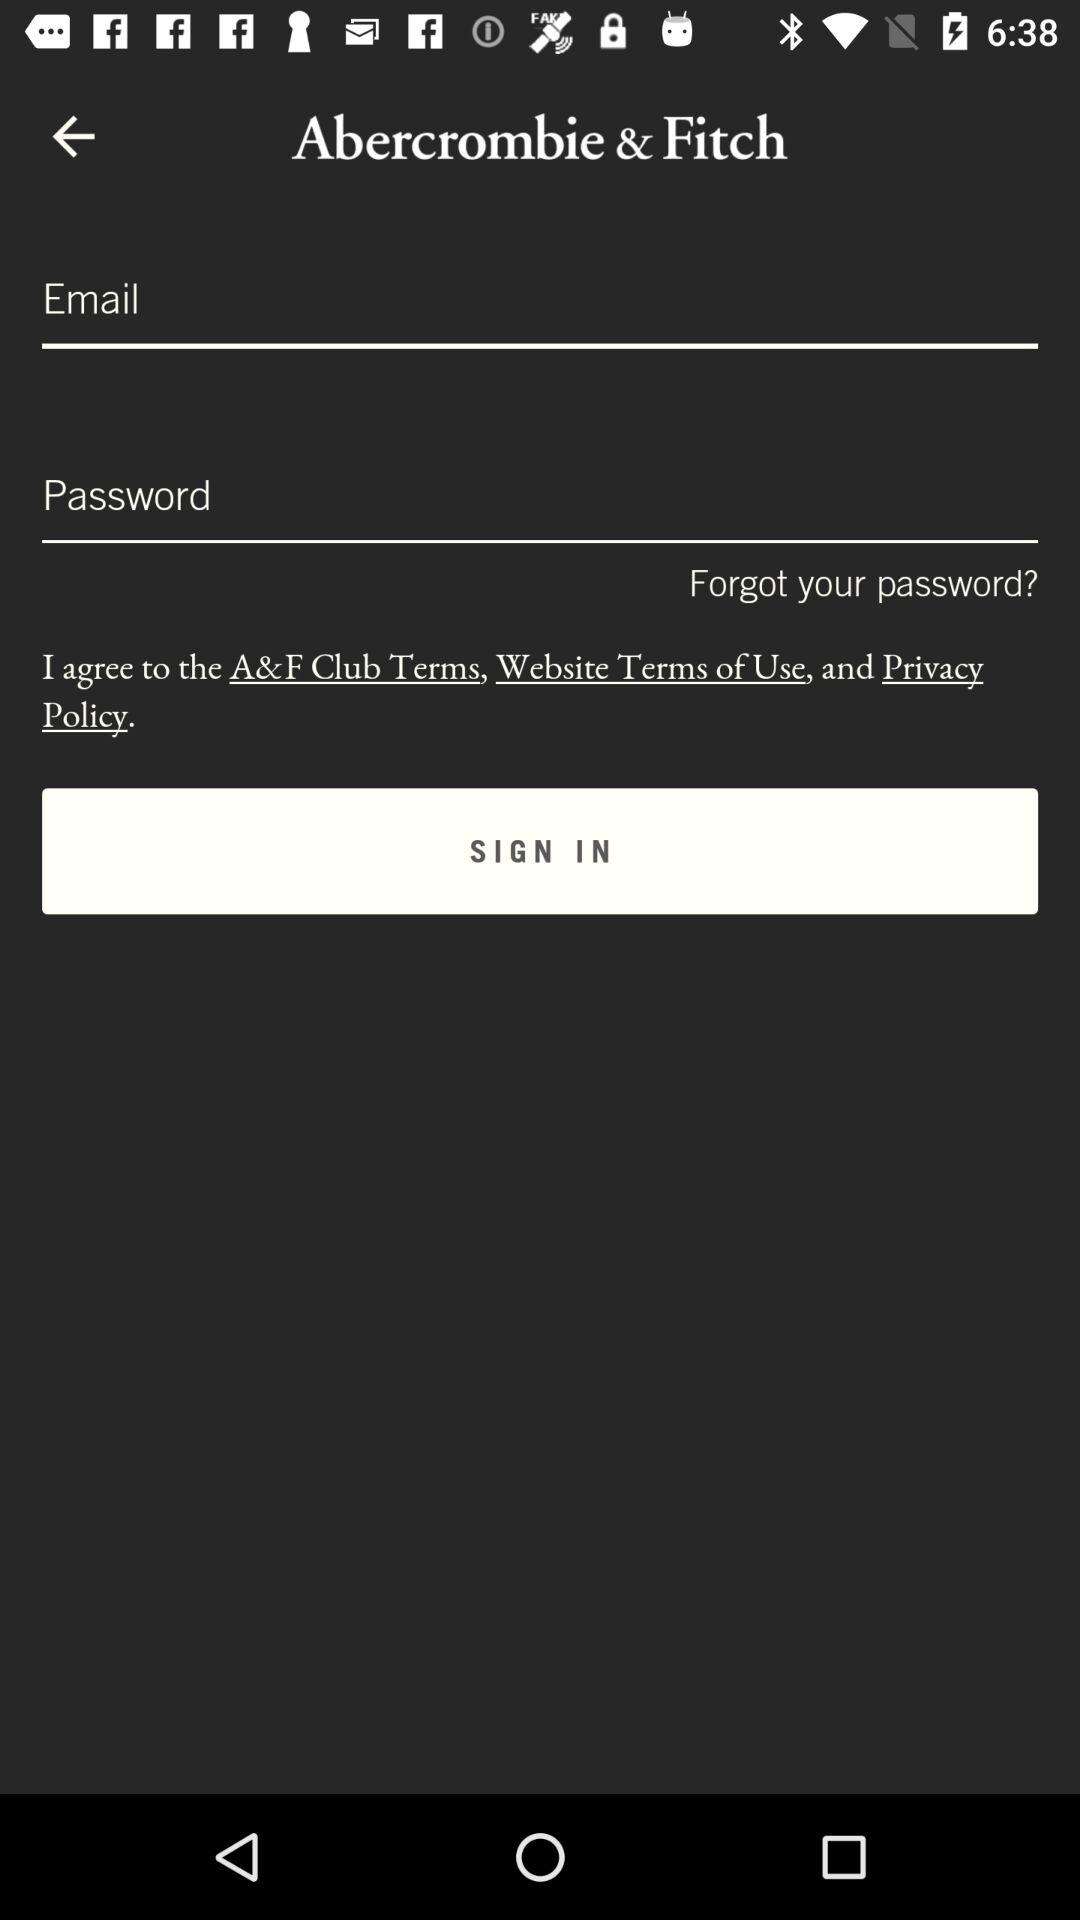What is the name of the sign page? The name of the sign page is "Abercrombie & Fitch". 